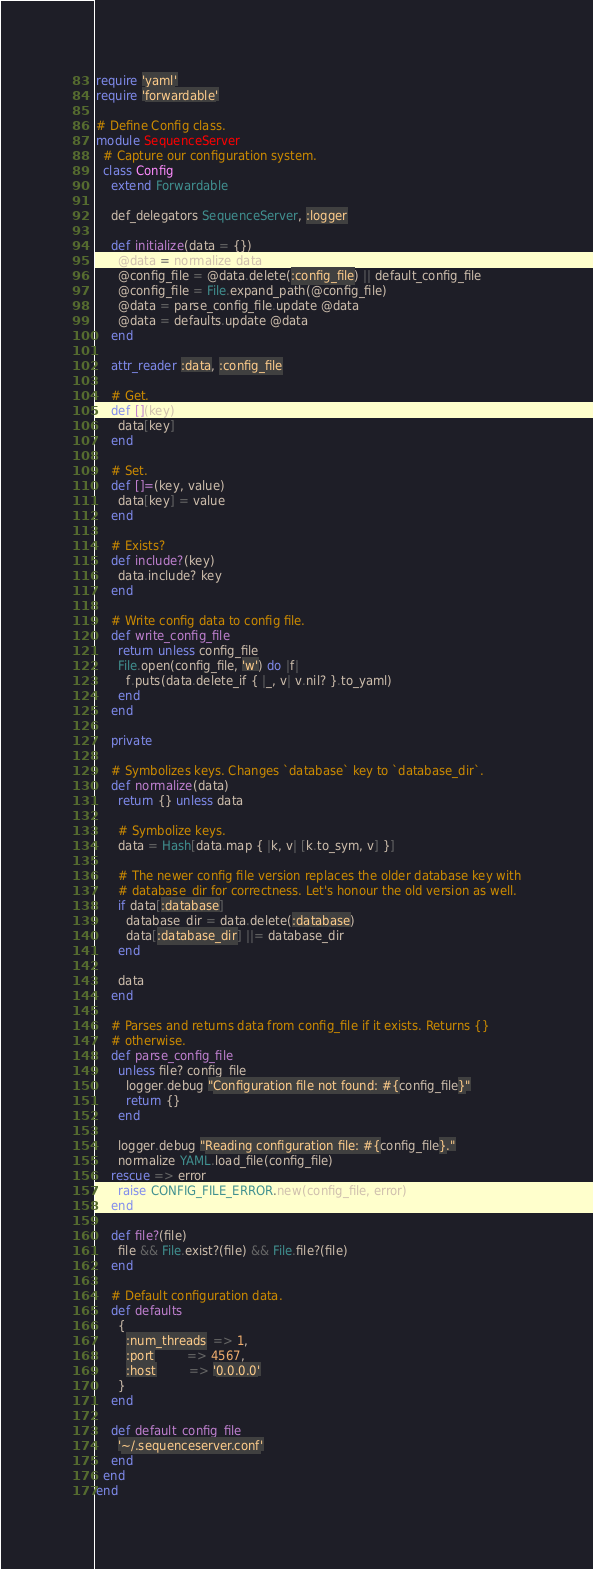Convert code to text. <code><loc_0><loc_0><loc_500><loc_500><_Ruby_>require 'yaml'
require 'forwardable'

# Define Config class.
module SequenceServer
  # Capture our configuration system.
  class Config
    extend Forwardable

    def_delegators SequenceServer, :logger

    def initialize(data = {})
      @data = normalize data
      @config_file = @data.delete(:config_file) || default_config_file
      @config_file = File.expand_path(@config_file)
      @data = parse_config_file.update @data
      @data = defaults.update @data
    end

    attr_reader :data, :config_file

    # Get.
    def [](key)
      data[key]
    end

    # Set.
    def []=(key, value)
      data[key] = value
    end

    # Exists?
    def include?(key)
      data.include? key
    end

    # Write config data to config file.
    def write_config_file
      return unless config_file
      File.open(config_file, 'w') do |f|
        f.puts(data.delete_if { |_, v| v.nil? }.to_yaml)
      end
    end

    private

    # Symbolizes keys. Changes `database` key to `database_dir`.
    def normalize(data)
      return {} unless data

      # Symbolize keys.
      data = Hash[data.map { |k, v| [k.to_sym, v] }]

      # The newer config file version replaces the older database key with
      # database_dir for correctness. Let's honour the old version as well.
      if data[:database]
        database_dir = data.delete(:database)
        data[:database_dir] ||= database_dir
      end

      data
    end

    # Parses and returns data from config_file if it exists. Returns {}
    # otherwise.
    def parse_config_file
      unless file? config_file
        logger.debug "Configuration file not found: #{config_file}"
        return {}
      end

      logger.debug "Reading configuration file: #{config_file}."
      normalize YAML.load_file(config_file)
    rescue => error
      raise CONFIG_FILE_ERROR.new(config_file, error)
    end

    def file?(file)
      file && File.exist?(file) && File.file?(file)
    end

    # Default configuration data.
    def defaults
      {
        :num_threads  => 1,
        :port         => 4567,
        :host         => '0.0.0.0'
      }
    end

    def default_config_file
      '~/.sequenceserver.conf'
    end
  end
end
</code> 